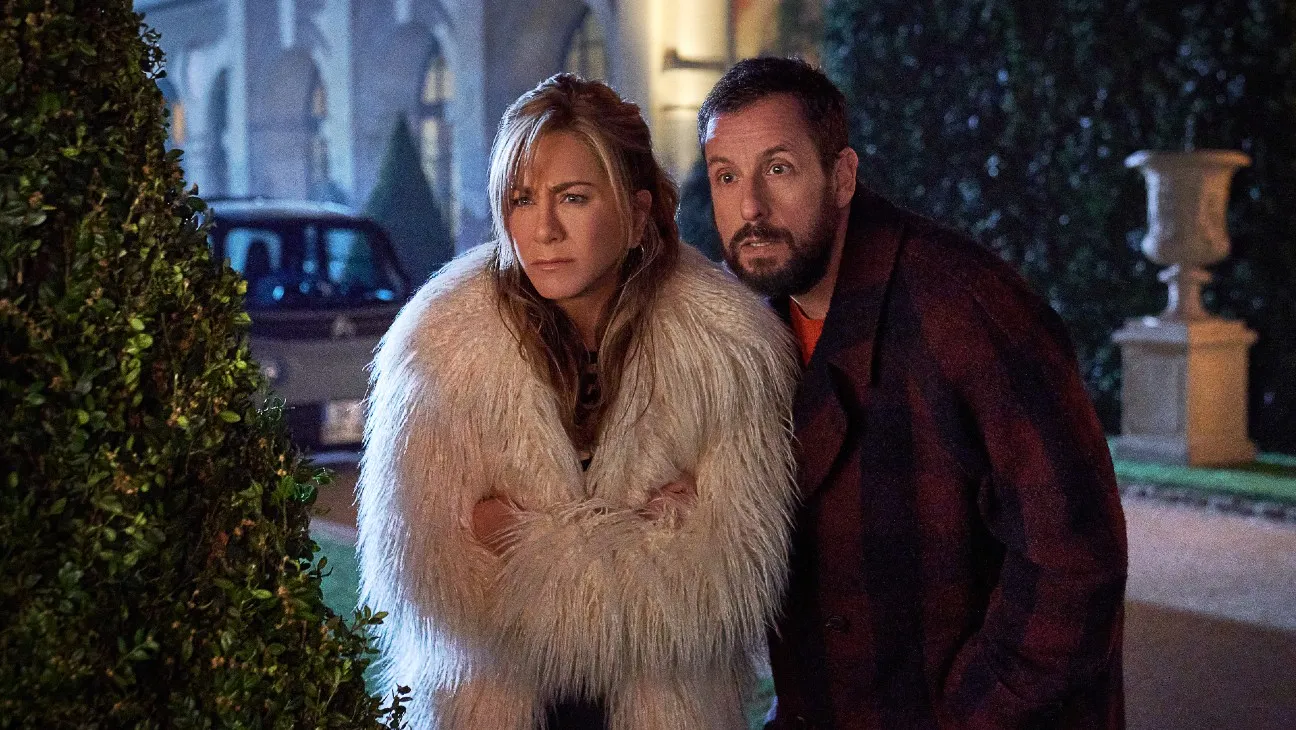Discuss the effect of the nighttime lighting in this image. The nighttime lighting casts a somber and mysterious glow on the subjects, accentuating their facial features and expressions while highlighting the details of their clothing. This lighting also contributes to the overall mood, making the scene appear more dramatic and intense, emphasizing the possible narrative significance of the moment captured. 